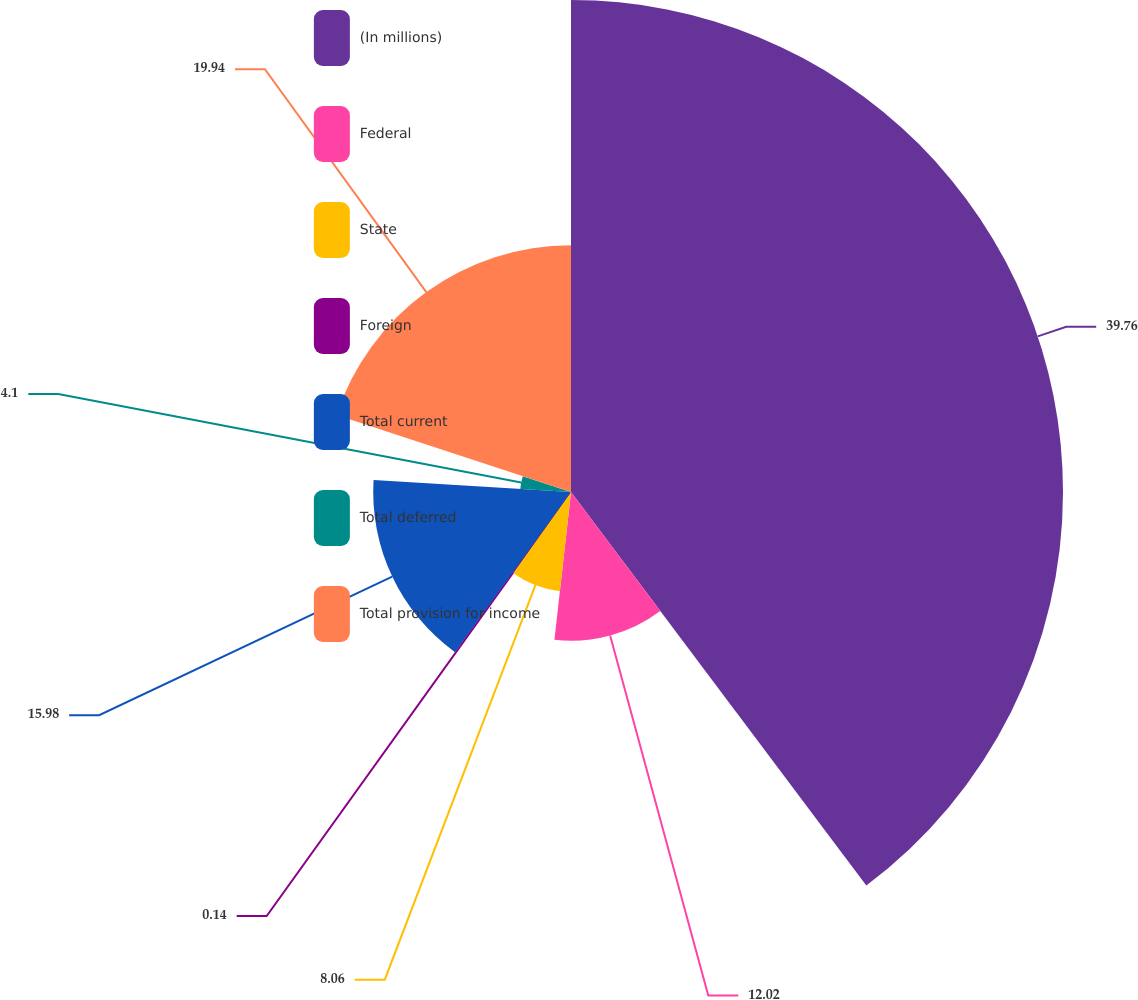Convert chart. <chart><loc_0><loc_0><loc_500><loc_500><pie_chart><fcel>(In millions)<fcel>Federal<fcel>State<fcel>Foreign<fcel>Total current<fcel>Total deferred<fcel>Total provision for income<nl><fcel>39.75%<fcel>12.02%<fcel>8.06%<fcel>0.14%<fcel>15.98%<fcel>4.1%<fcel>19.94%<nl></chart> 